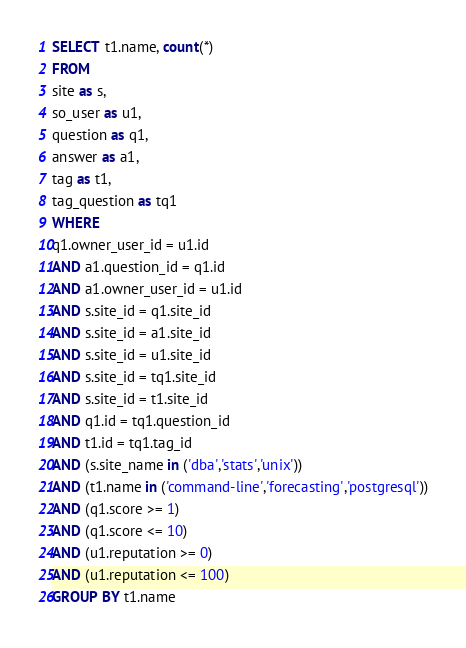<code> <loc_0><loc_0><loc_500><loc_500><_SQL_>SELECT t1.name, count(*)
FROM
site as s,
so_user as u1,
question as q1,
answer as a1,
tag as t1,
tag_question as tq1
WHERE
q1.owner_user_id = u1.id
AND a1.question_id = q1.id
AND a1.owner_user_id = u1.id
AND s.site_id = q1.site_id
AND s.site_id = a1.site_id
AND s.site_id = u1.site_id
AND s.site_id = tq1.site_id
AND s.site_id = t1.site_id
AND q1.id = tq1.question_id
AND t1.id = tq1.tag_id
AND (s.site_name in ('dba','stats','unix'))
AND (t1.name in ('command-line','forecasting','postgresql'))
AND (q1.score >= 1)
AND (q1.score <= 10)
AND (u1.reputation >= 0)
AND (u1.reputation <= 100)
GROUP BY t1.name</code> 